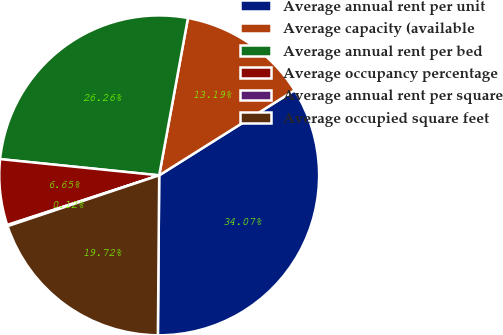Convert chart to OTSL. <chart><loc_0><loc_0><loc_500><loc_500><pie_chart><fcel>Average annual rent per unit<fcel>Average capacity (available<fcel>Average annual rent per bed<fcel>Average occupancy percentage<fcel>Average annual rent per square<fcel>Average occupied square feet<nl><fcel>34.07%<fcel>13.19%<fcel>26.26%<fcel>6.65%<fcel>0.12%<fcel>19.72%<nl></chart> 